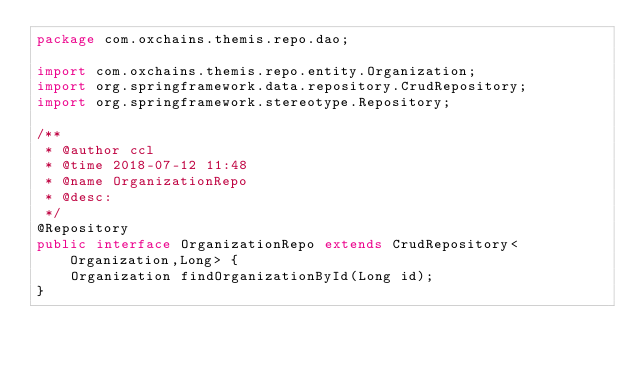<code> <loc_0><loc_0><loc_500><loc_500><_Java_>package com.oxchains.themis.repo.dao;

import com.oxchains.themis.repo.entity.Organization;
import org.springframework.data.repository.CrudRepository;
import org.springframework.stereotype.Repository;

/**
 * @author ccl
 * @time 2018-07-12 11:48
 * @name OrganizationRepo
 * @desc:
 */
@Repository
public interface OrganizationRepo extends CrudRepository<Organization,Long> {
    Organization findOrganizationById(Long id);
}
</code> 